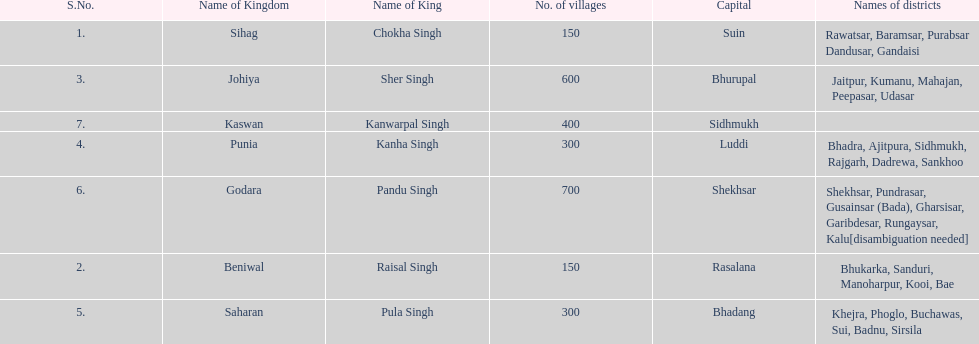Which kingdom has the most villages? Godara. 